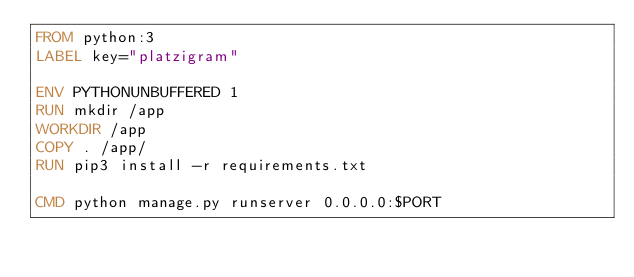Convert code to text. <code><loc_0><loc_0><loc_500><loc_500><_Dockerfile_>FROM python:3
LABEL key="platzigram" 

ENV PYTHONUNBUFFERED 1
RUN mkdir /app
WORKDIR /app
COPY . /app/
RUN pip3 install -r requirements.txt

CMD python manage.py runserver 0.0.0.0:$PORT</code> 